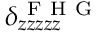Convert formula to latex. <formula><loc_0><loc_0><loc_500><loc_500>\delta _ { z z z z z } ^ { F H G }</formula> 